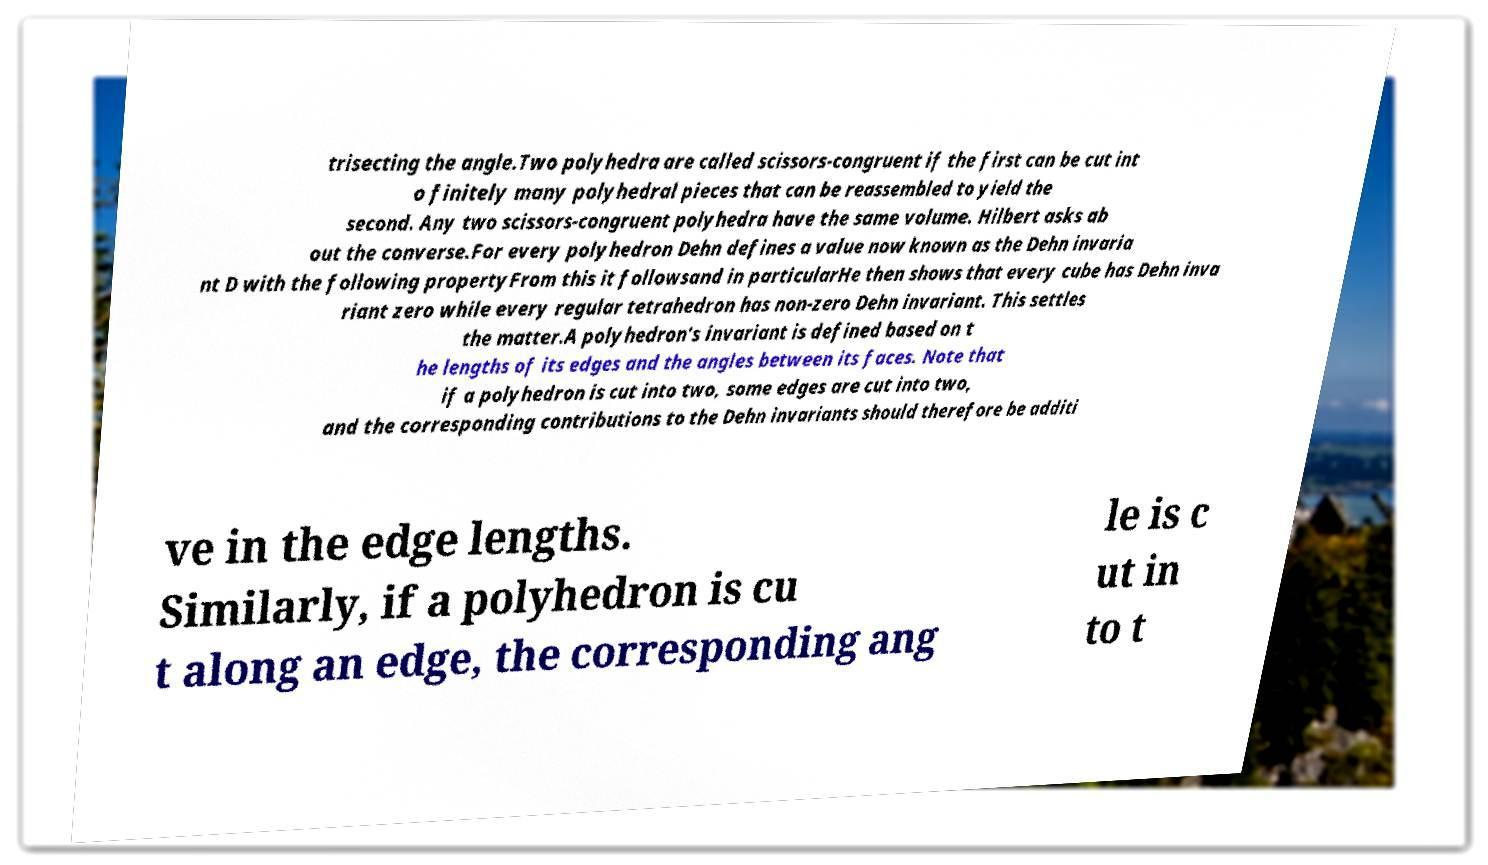Could you extract and type out the text from this image? trisecting the angle.Two polyhedra are called scissors-congruent if the first can be cut int o finitely many polyhedral pieces that can be reassembled to yield the second. Any two scissors-congruent polyhedra have the same volume. Hilbert asks ab out the converse.For every polyhedron Dehn defines a value now known as the Dehn invaria nt D with the following propertyFrom this it followsand in particularHe then shows that every cube has Dehn inva riant zero while every regular tetrahedron has non-zero Dehn invariant. This settles the matter.A polyhedron's invariant is defined based on t he lengths of its edges and the angles between its faces. Note that if a polyhedron is cut into two, some edges are cut into two, and the corresponding contributions to the Dehn invariants should therefore be additi ve in the edge lengths. Similarly, if a polyhedron is cu t along an edge, the corresponding ang le is c ut in to t 